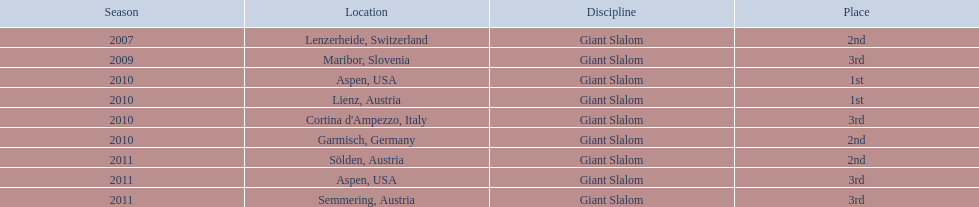The final race finishing place was not 1st but what other place? 3rd. 